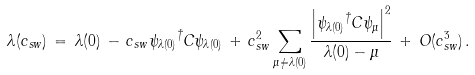<formula> <loc_0><loc_0><loc_500><loc_500>\lambda ( c _ { s w } ) \, = \, \lambda ( 0 ) \, - \, c _ { s w } { \psi _ { \lambda ( 0 ) } } ^ { \dagger } C \psi _ { \lambda ( 0 ) } \, + \, c _ { s w } ^ { 2 } \sum _ { \mu \neq \lambda ( 0 ) } \frac { \left | { \psi _ { \lambda ( 0 ) } } ^ { \dagger } C \psi _ { \mu } \right | ^ { 2 } } { \lambda ( 0 ) - \mu } \, + \, O ( c _ { s w } ^ { 3 } ) \, .</formula> 